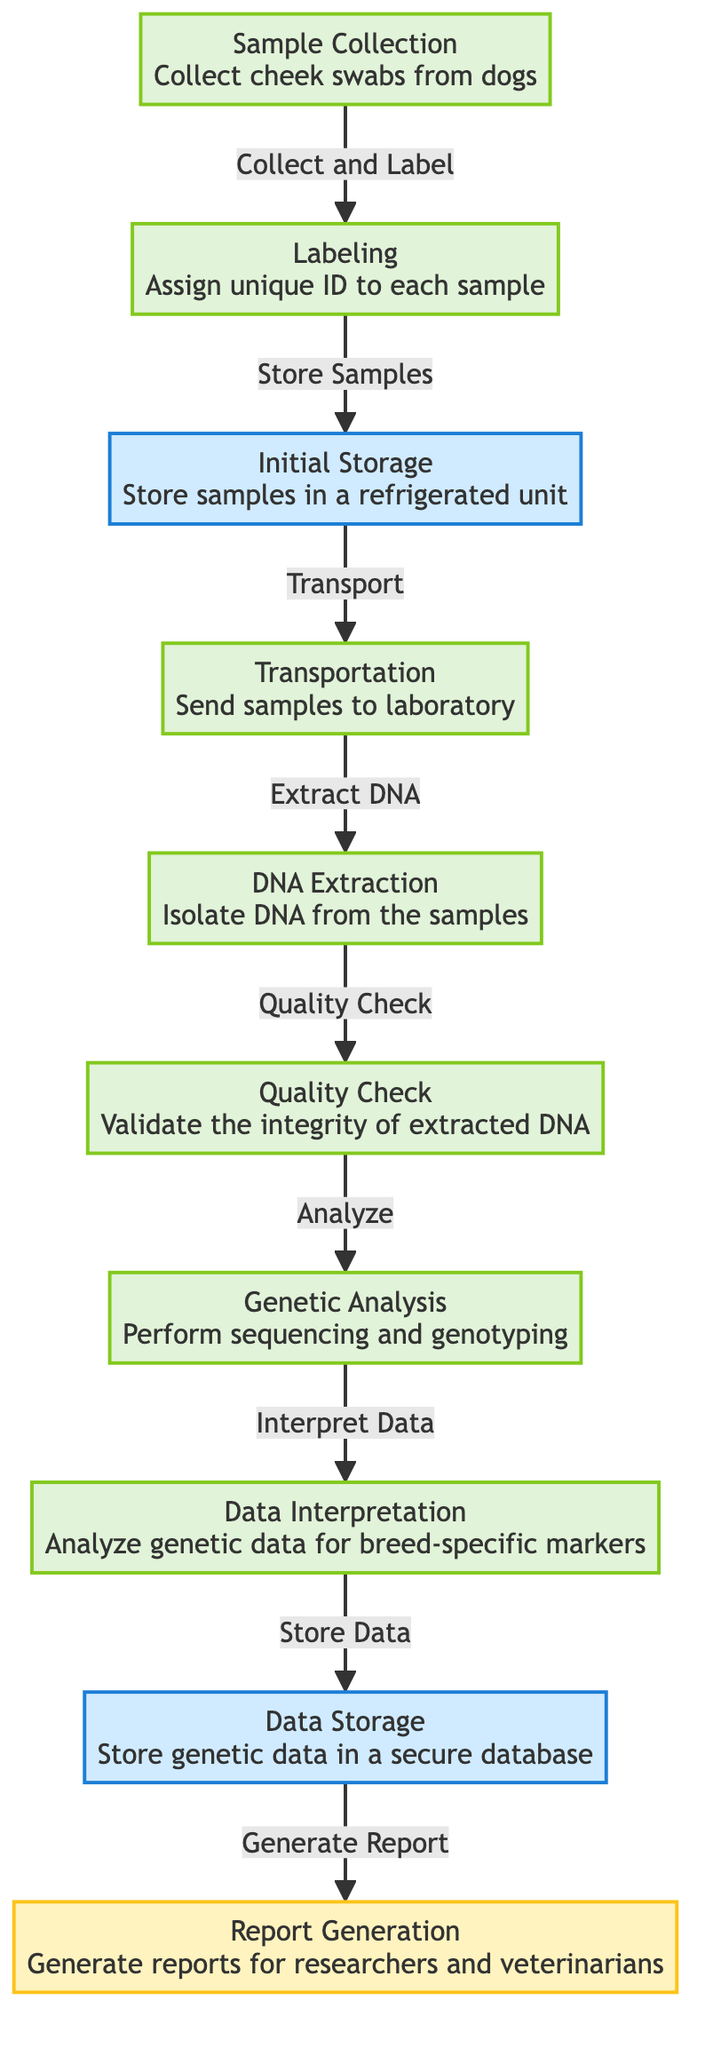What is the first step in the workflow? The first node in the flowchart is "Sample Collection," which specifies that cheek swabs from dogs are collected. Therefore, the first step is directly identified as this action.
Answer: Sample Collection How many main steps are involved in the workflow? By counting the distinct nodes in the flowchart, there are a total of 10 steps represented in the diagram. This includes all processes from sample collection to report generation.
Answer: 10 What type of storage method is used after sample collection? The process following sample collection is "Initial Storage," which indicates that samples are stored in a refrigerated unit. The diagram specifies the nature of this storage directly.
Answer: Refrigerated unit What action occurs immediately after "Transportation"? The next step that follows "Transportation" is "DNA Extraction," indicating that the samples are isolated for DNA processing right after they have been transported to the laboratory.
Answer: DNA Extraction What is the last step in the workflow? The final node in the flowchart is "Report Generation," where reports for researchers and veterinarians are generated. This identifies the last action taken in the entire workflow process.
Answer: Report Generation What step is associated with validating the DNA? The step that deals with this process is called "Quality Check." This stage focuses on ensuring the integrity of the extracted DNA, indicating its importance within the workflow.
Answer: Quality Check What is the main purpose of the "Data Interpretation" step? "Data Interpretation" is focused on analyzing genetic data for breed-specific markers, which is crucial for understanding the genetic composition of the samples collected. Thus, the purpose revolves around breed-specific understanding.
Answer: Analyze genetic data for breed-specific markers Which steps are classified as storage? The steps classified as storage include "Initial Storage" and "Data Storage." These nodes specifically identify the actions related to how samples and genetic data are retained securely.
Answer: Initial Storage, Data Storage What action is required before "Genetic Analysis"? Prior to reaching "Genetic Analysis," the workflow mandates going through "Quality Check," ensuring that the DNA is validated before any sequencing and genotyping can be performed.
Answer: Quality Check 